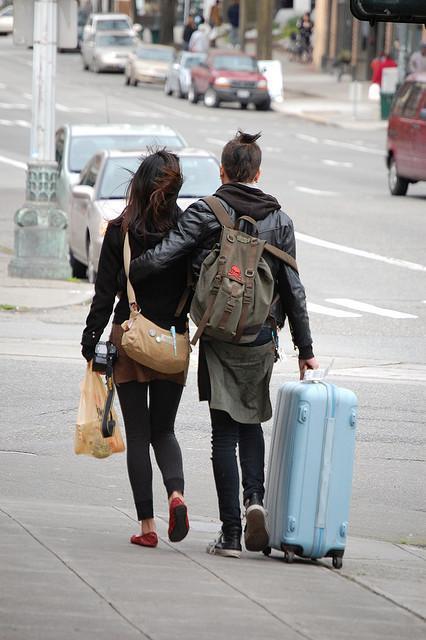What type of parking is available?
Pick the right solution, then justify: 'Answer: answer
Rationale: rationale.'
Options: Valet, diagonal, lot, street. Answer: street.
Rationale: There are vehicles parked closely together on the sides of the visible street. based on the lines and the setting, answer a is consistent. 